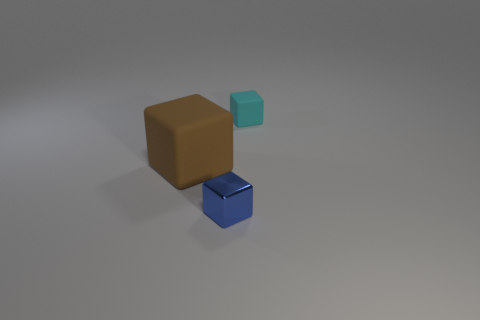Add 3 cyan blocks. How many objects exist? 6 Subtract all tiny shiny things. Subtract all small matte blocks. How many objects are left? 1 Add 2 metal blocks. How many metal blocks are left? 3 Add 3 tiny cyan rubber blocks. How many tiny cyan rubber blocks exist? 4 Subtract 0 blue spheres. How many objects are left? 3 